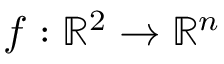Convert formula to latex. <formula><loc_0><loc_0><loc_500><loc_500>f \colon \mathbb { R } ^ { 2 } \to \mathbb { R } ^ { n }</formula> 